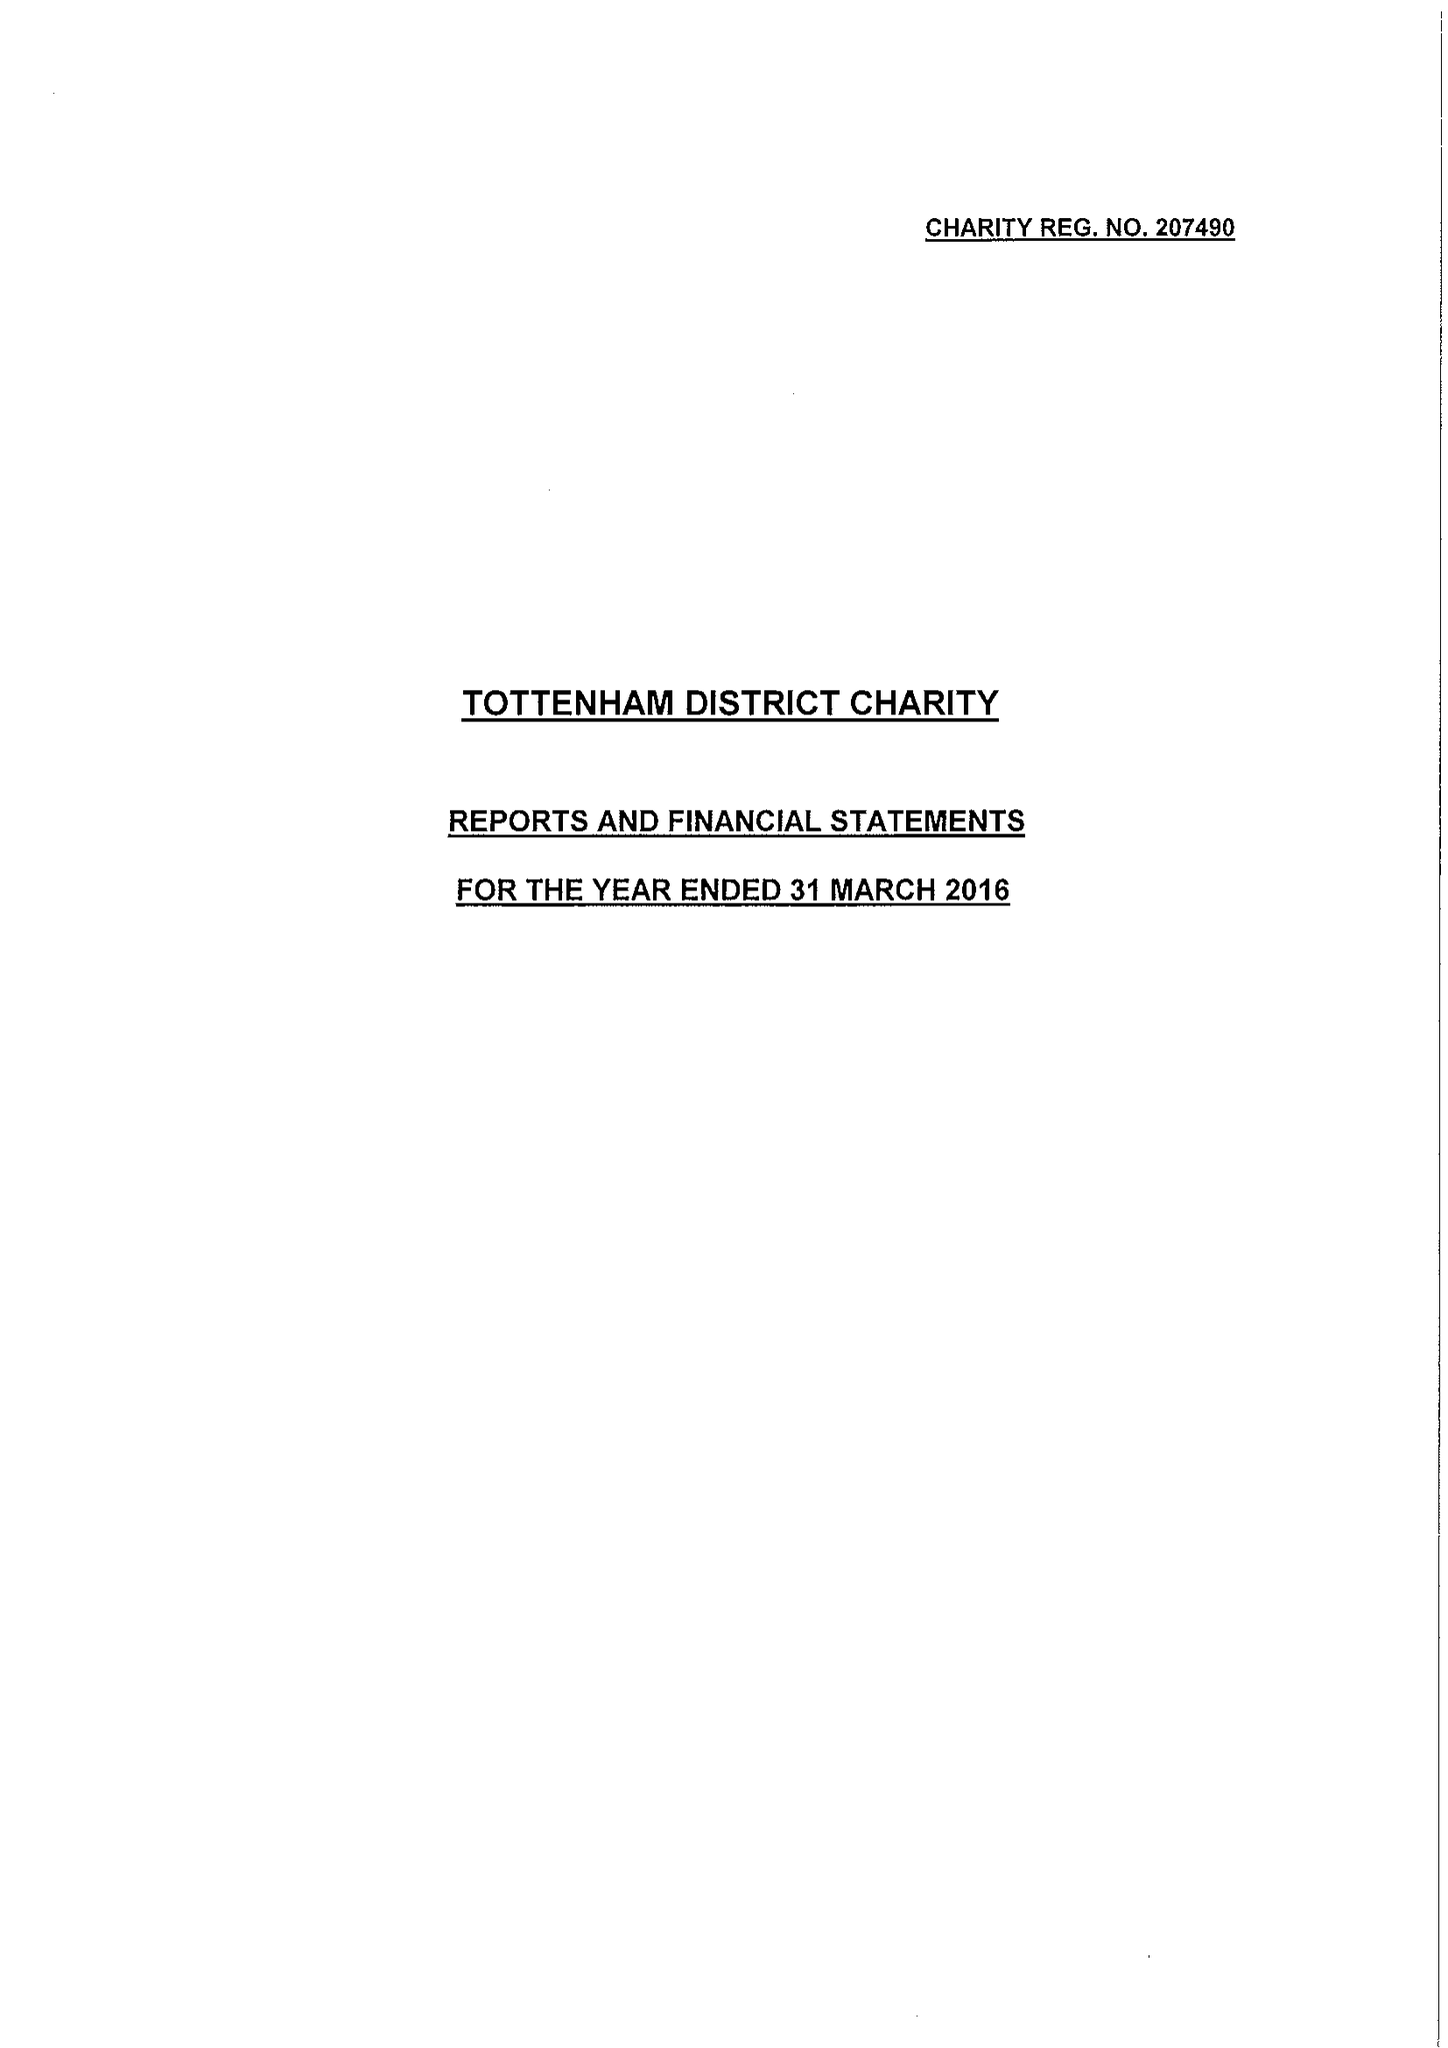What is the value for the charity_number?
Answer the question using a single word or phrase. 207490 